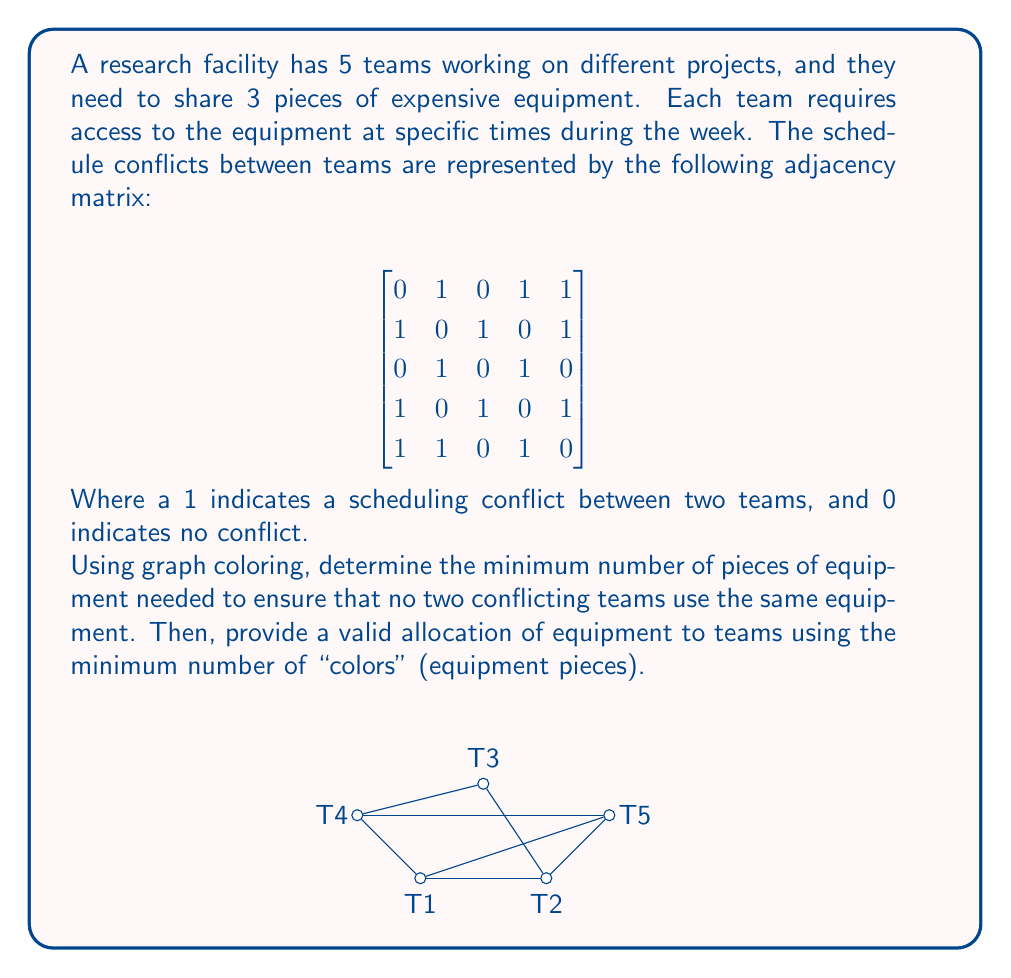Provide a solution to this math problem. To solve this graph coloring problem, we'll follow these steps:

1) First, we need to understand that the adjacency matrix represents a graph where each team is a vertex, and conflicts are edges between vertices.

2) The graph coloring problem asks us to assign colors to vertices such that no two adjacent vertices have the same color. In this context, colors represent pieces of equipment.

3) We'll use the greedy coloring algorithm:
   a) Order the vertices (teams) arbitrarily: T1, T2, T3, T4, T5
   b) Assign the first available color to each vertex, ensuring no conflicts

4) Coloring process:
   - T1: Assign color 1
   - T2: Connected to T1, so assign color 2
   - T3: Connected to T2, so assign color 1
   - T4: Connected to T1 and T3, so assign color 3
   - T5: Connected to T1, T2, and T4, so assign color 3

5) After this process, we use 3 colors, which means we need a minimum of 3 pieces of equipment.

6) The final allocation is:
   Equipment 1 (Color 1): T1, T3
   Equipment 2 (Color 2): T2
   Equipment 3 (Color 3): T4, T5

This allocation ensures that no two conflicting teams use the same equipment.
Answer: Minimum number of equipment pieces needed: 3

Allocation:
Equipment 1: Teams 1 and 3
Equipment 2: Team 2
Equipment 3: Teams 4 and 5 